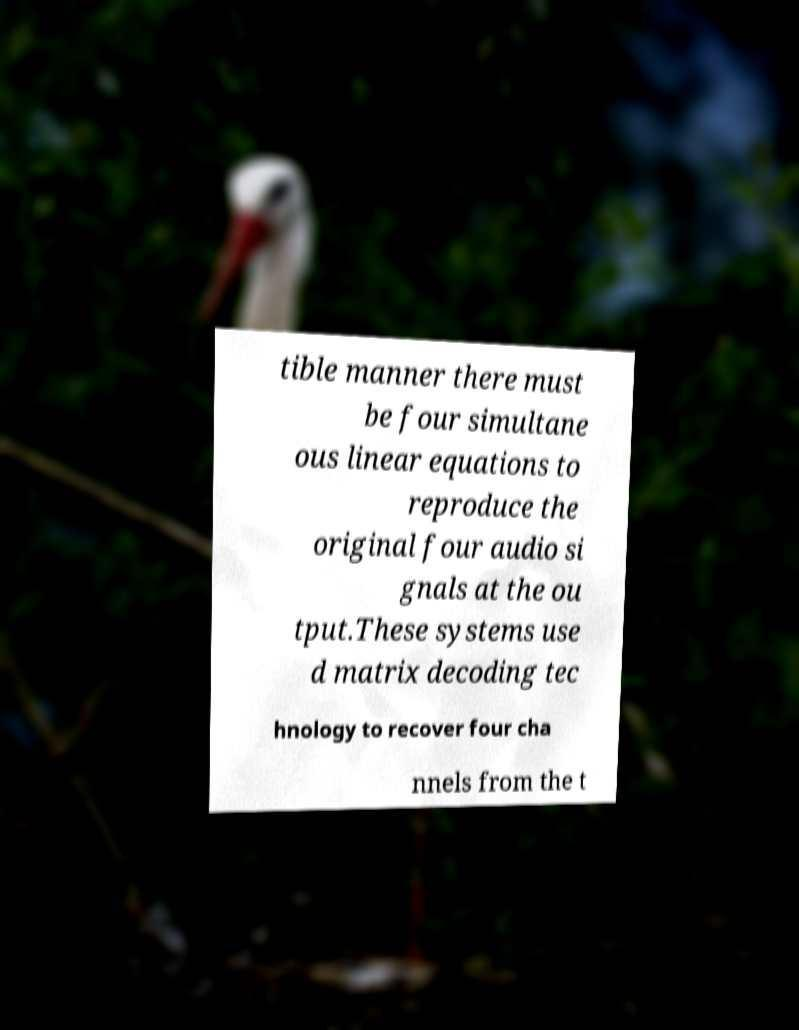Please read and relay the text visible in this image. What does it say? tible manner there must be four simultane ous linear equations to reproduce the original four audio si gnals at the ou tput.These systems use d matrix decoding tec hnology to recover four cha nnels from the t 